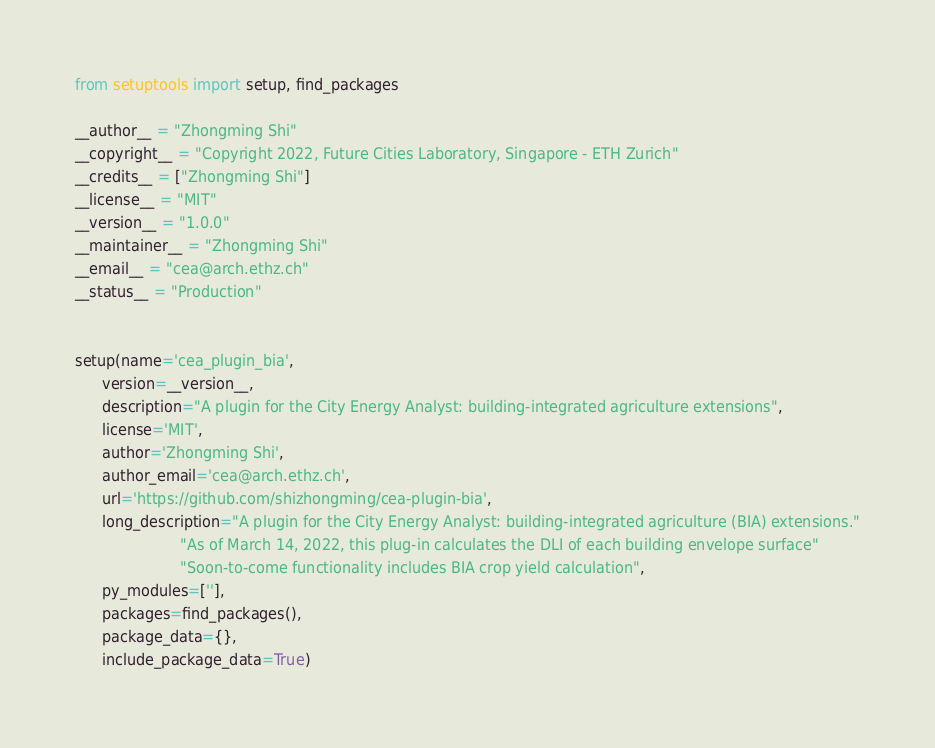<code> <loc_0><loc_0><loc_500><loc_500><_Python_>from setuptools import setup, find_packages

__author__ = "Zhongming Shi"
__copyright__ = "Copyright 2022, Future Cities Laboratory, Singapore - ETH Zurich"
__credits__ = ["Zhongming Shi"]
__license__ = "MIT"
__version__ = "1.0.0"
__maintainer__ = "Zhongming Shi"
__email__ = "cea@arch.ethz.ch"
__status__ = "Production"


setup(name='cea_plugin_bia',
      version=__version__,
      description="A plugin for the City Energy Analyst: building-integrated agriculture extensions",
      license='MIT',
      author='Zhongming Shi',
      author_email='cea@arch.ethz.ch',
      url='https://github.com/shizhongming/cea-plugin-bia',
      long_description="A plugin for the City Energy Analyst: building-integrated agriculture (BIA) extensions."
                       "As of March 14, 2022, this plug-in calculates the DLI of each building envelope surface"
                       "Soon-to-come functionality includes BIA crop yield calculation",
      py_modules=[''],
      packages=find_packages(),
      package_data={},
      include_package_data=True)
</code> 